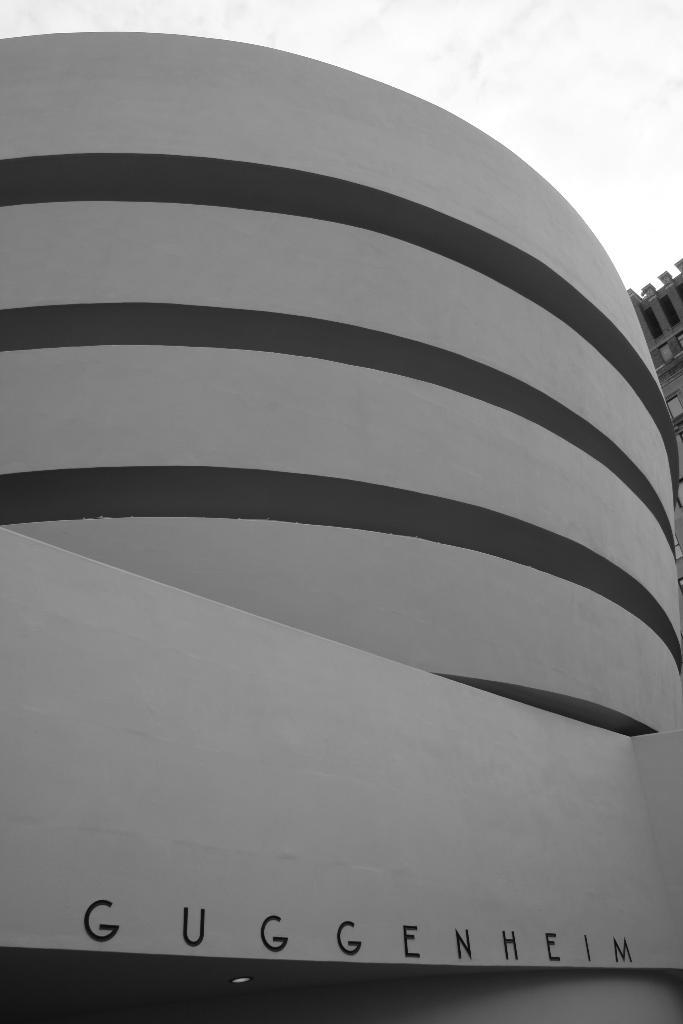What is written on the building in the image? There is a building with a name on it in the image. Can you describe the surrounding area of the building? There is another building beside the first building in the image. What type of soup is being served in the building? There is no information about soup being served in the image, as it only shows two buildings. 